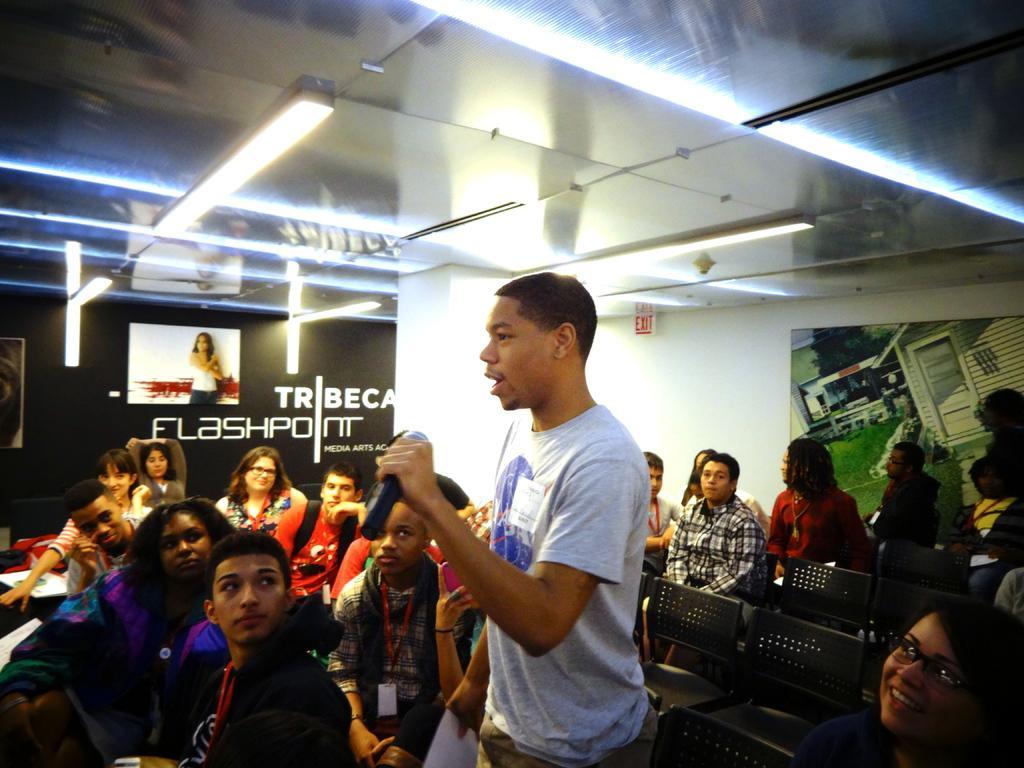Please provide a concise description of this image. In this image I can see a person wearing grey and blue colored dress is standing and holding a microphone in his hand. I can see number of persons are sitting on black colored chairs around him. In the background I can see the white colored wall, the ceiling, few lights to the ceiling, the black colored wall and few posts attached to the wall. 